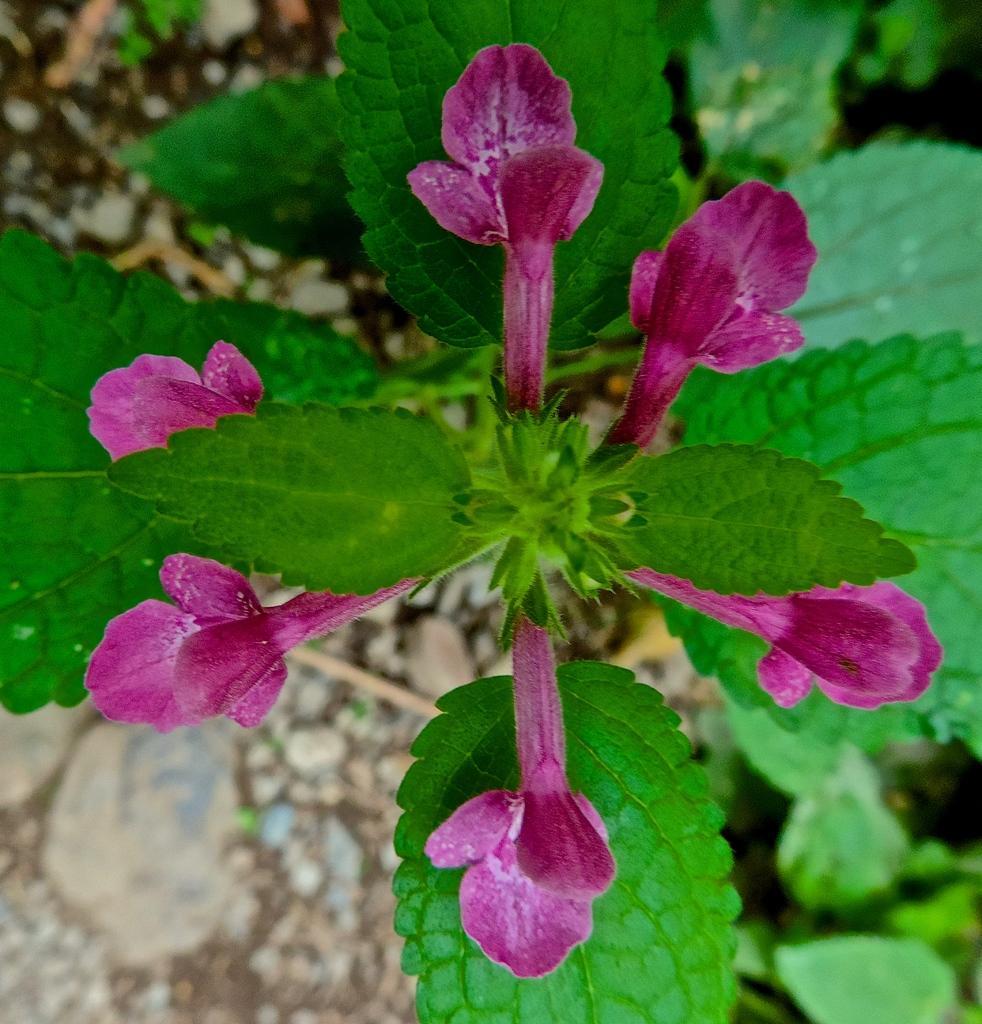In one or two sentences, can you explain what this image depicts? In this image there are plants with the flowers on it. At the bottom there are stones on the surface. 